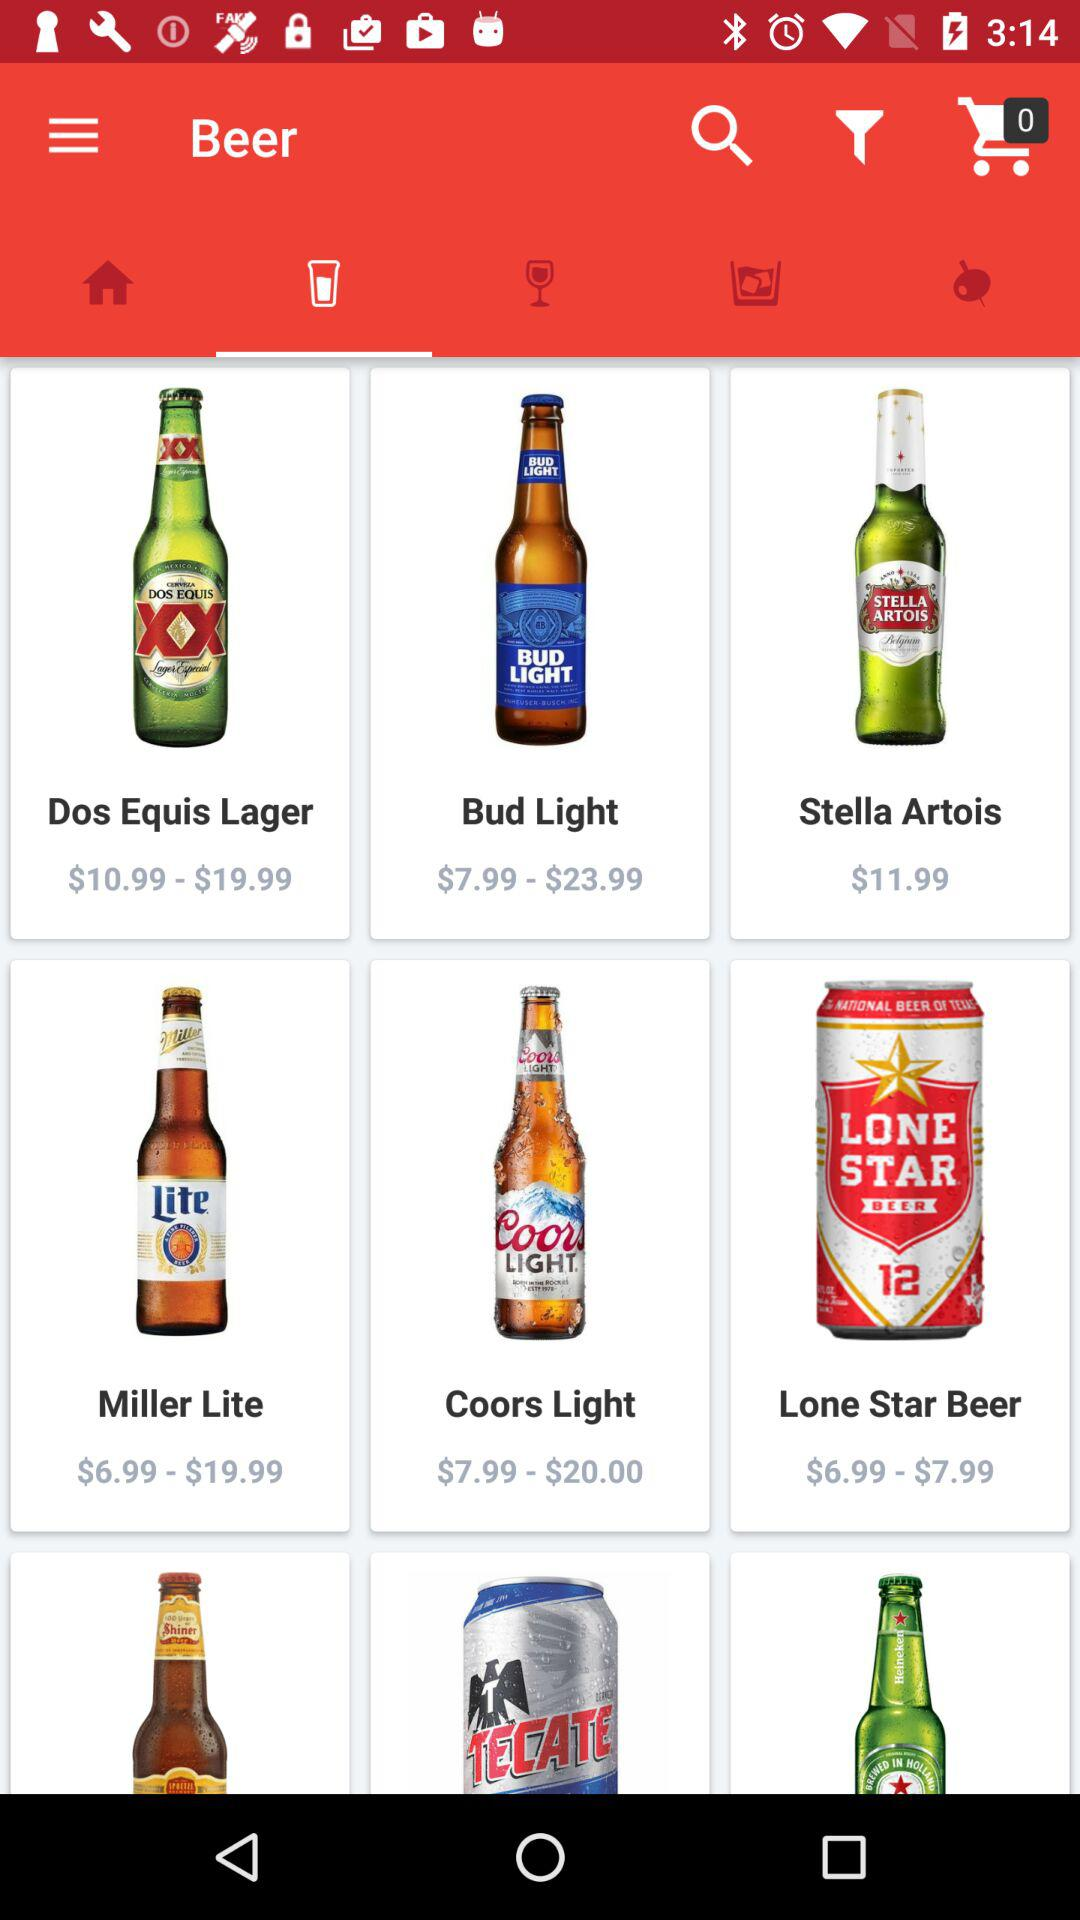What is the price range of the "Dos Equis Lager" beer? The price ranges from $10.99 to $19.99. 